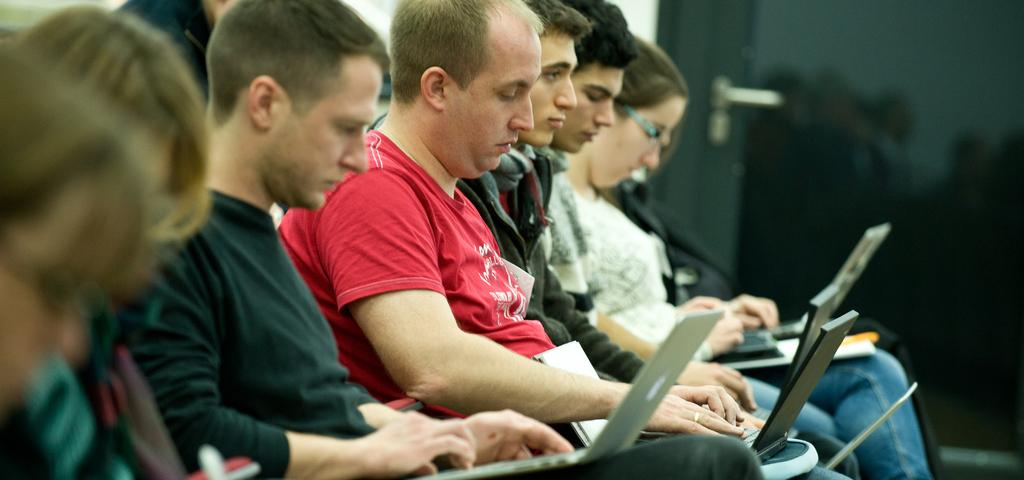What are the people in the image doing? The people in the image are sitting on chairs. What objects are the people holding in their laps? The people are holding laptops in their laps. Can you describe the background of the image? The background of the image is blurred. What type of frog can be seen sitting on a twig in the image? There is no frog or twig present in the image; it features people sitting on chairs and holding laptops. How many yaks are visible in the image? There are no yaks present in the image. 